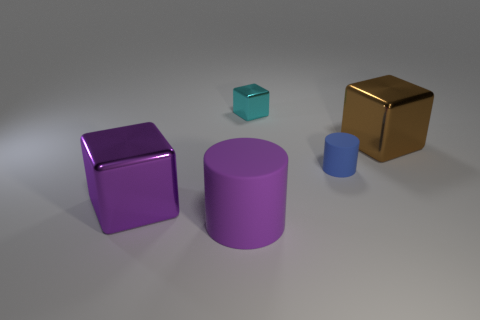Subtract all cyan cylinders. Subtract all brown balls. How many cylinders are left? 2 Add 5 purple cylinders. How many objects exist? 10 Subtract all cylinders. How many objects are left? 3 Add 5 purple things. How many purple things are left? 7 Add 5 tiny cyan shiny objects. How many tiny cyan shiny objects exist? 6 Subtract 0 blue blocks. How many objects are left? 5 Subtract all small rubber cylinders. Subtract all purple cylinders. How many objects are left? 3 